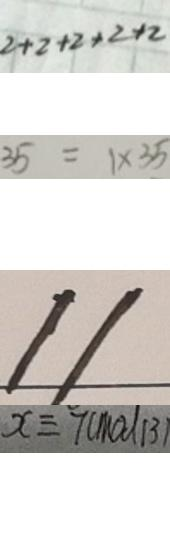<formula> <loc_0><loc_0><loc_500><loc_500>2 + 2 + 2 + 2 + 2 
 3 5 = 1 \times 3 5 
 1 1 
 x \equiv 7 ( m o d 1 3 )</formula> 